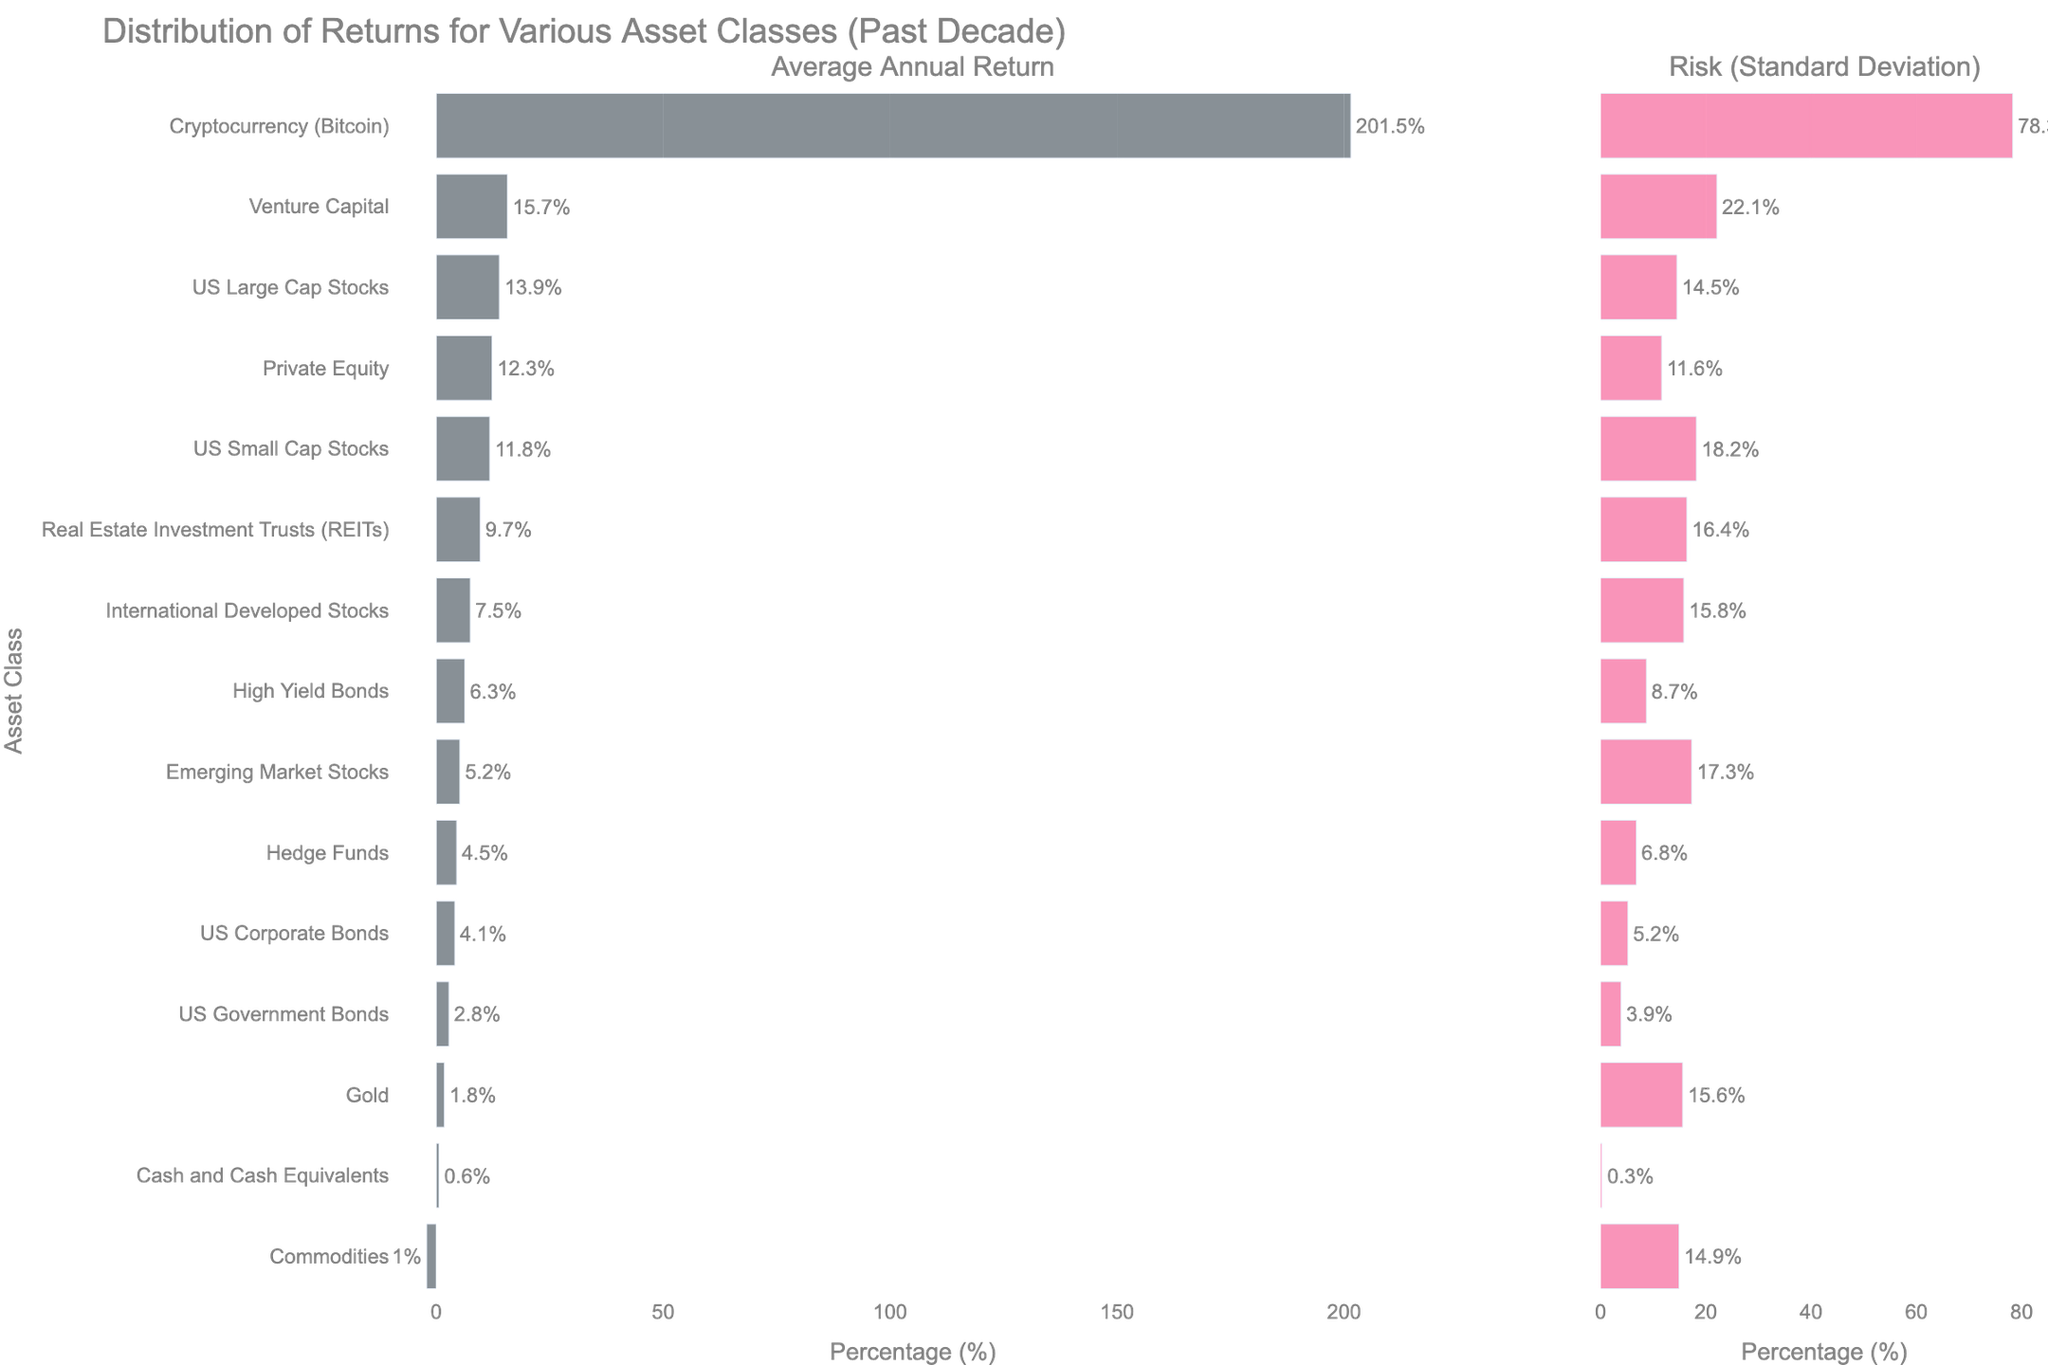Which asset class has the highest average annual return? The highest average annual return is represented by the longest bar in the "Average Annual Return" subplot, which belongs to Cryptocurrency (Bitcoin).
Answer: Cryptocurrency (Bitcoin) Which asset class has the lowest average annual return? The lowest average annual return is represented by the shortest bar in the "Average Annual Return" subplot, which belongs to Commodities.
Answer: Commodities What is the standard deviation for Venture Capital? Locate Venture Capital in the "Risk (Standard Deviation)" subplot. The bar shows a standard deviation value, given by the text at the end of the bar, which is 22.1%.
Answer: 22.1% Compare the average annual returns of US Large Cap Stocks and US Small Cap Stocks. Which one is higher and by how much? Find the bars representing US Large Cap Stocks and US Small Cap Stocks in the "Average Annual Return" subplot. The values are 13.9% for US Large Cap Stocks and 11.8% for US Small Cap Stocks. Subtract the smaller value from the larger one: 13.9% - 11.8% = 2.1%.
Answer: US Large Cap Stocks by 2.1% Which asset class has the greatest risk (highest standard deviation)? The greatest risk is indicated by the longest bar in the "Risk (Standard Deviation)" subplot, which belongs to Cryptocurrency (Bitcoin).
Answer: Cryptocurrency (Bitcoin) What is the difference in average annual return between Hedge Funds and Private Equity? Locate the average annual returns for Hedge Funds and Private Equity in the "Average Annual Return" subplot. The values are 4.5% for Hedge Funds and 12.3% for Private Equity. Subtract the smaller value from the larger one: 12.3% - 4.5% = 7.8%.
Answer: 7.8% Identify the asset class with the highest average annual return and highest risk. Are they the same? In the "Average Annual Return" subplot, the highest return is for Cryptocurrency (Bitcoin) (201.5%). In the "Risk (Standard Deviation)" subplot, the highest risk is also for Cryptocurrency (Bitcoin) (78.3%).
Answer: Yes, Cryptocurrency (Bitcoin) What is the combined average annual return of US Government Bonds, US Corporate Bonds, and High Yield Bonds? Sum their average annual returns from the "Average Annual Return" subplot: US Government Bonds (2.8%) + US Corporate Bonds (4.1%) + High Yield Bonds (6.3%) = 13.2%.
Answer: 13.2% Compare the risk of US Small Cap Stocks and International Developed Stocks. Which one is riskier? Find the standard deviations for US Small Cap Stocks and International Developed Stocks in the "Risk (Standard Deviation)" subplot. The values are 18.2% for US Small Cap Stocks and 15.8% for International Developed Stocks. The higher value indicates higher risk.
Answer: US Small Cap Stocks What is the difference in risk between Real Estate Investment Trusts (REITs) and Commodities? Locate the standard deviations for REITs and Commodities in the "Risk (Standard Deviation)" subplot. The values are 16.4% for REITs and 14.9% for Commodities. Subtract the smaller value from the larger one: 16.4% - 14.9% = 1.5%.
Answer: 1.5% 